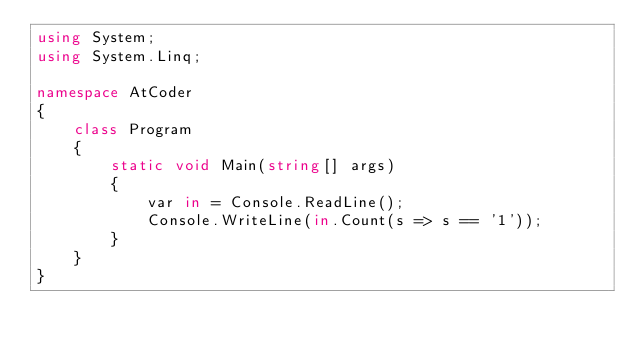Convert code to text. <code><loc_0><loc_0><loc_500><loc_500><_C#_>using System;
using System.Linq;

namespace AtCoder
{
    class Program
    {
        static void Main(string[] args)
        {
            var in = Console.ReadLine();
            Console.WriteLine(in.Count(s => s == '1'));
        }
    }
}

</code> 